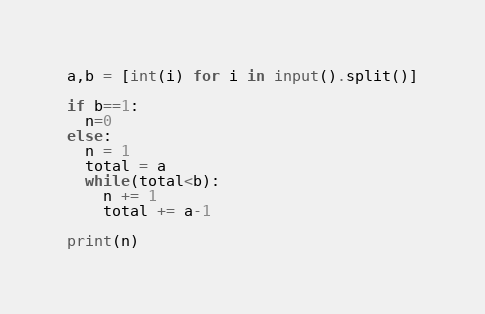Convert code to text. <code><loc_0><loc_0><loc_500><loc_500><_Python_>a,b = [int(i) for i in input().split()]

if b==1:
  n=0
else:
  n = 1
  total = a
  while(total<b):
    n += 1
    total += a-1
  
print(n)
</code> 